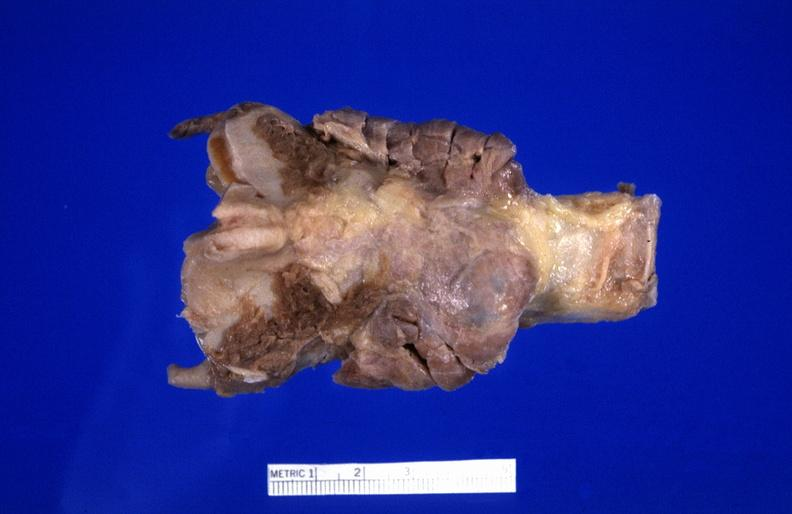what does this image show?
Answer the question using a single word or phrase. Hashimoto 's thyroiditis 